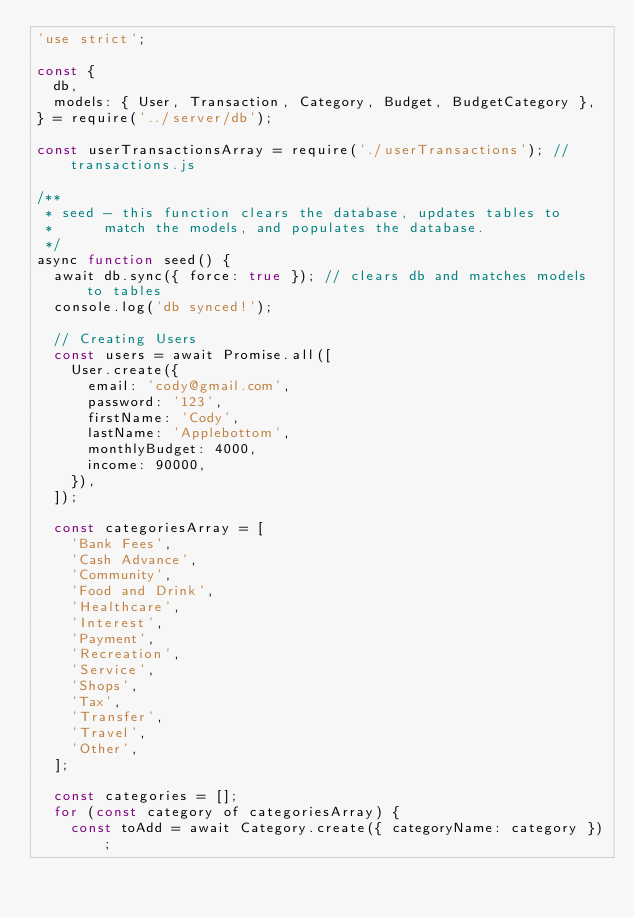Convert code to text. <code><loc_0><loc_0><loc_500><loc_500><_JavaScript_>'use strict';

const {
  db,
  models: { User, Transaction, Category, Budget, BudgetCategory },
} = require('../server/db');

const userTransactionsArray = require('./userTransactions'); //transactions.js

/**
 * seed - this function clears the database, updates tables to
 *      match the models, and populates the database.
 */
async function seed() {
  await db.sync({ force: true }); // clears db and matches models to tables
  console.log('db synced!');

  // Creating Users
  const users = await Promise.all([
    User.create({
      email: 'cody@gmail.com',
      password: '123',
      firstName: 'Cody',
      lastName: 'Applebottom',
      monthlyBudget: 4000,
      income: 90000,
    }),
  ]);

  const categoriesArray = [
    'Bank Fees',
    'Cash Advance',
    'Community',
    'Food and Drink',
    'Healthcare',
    'Interest',
    'Payment',
    'Recreation',
    'Service',
    'Shops',
    'Tax',
    'Transfer',
    'Travel',
    'Other',
  ];

  const categories = [];
  for (const category of categoriesArray) {
    const toAdd = await Category.create({ categoryName: category });</code> 